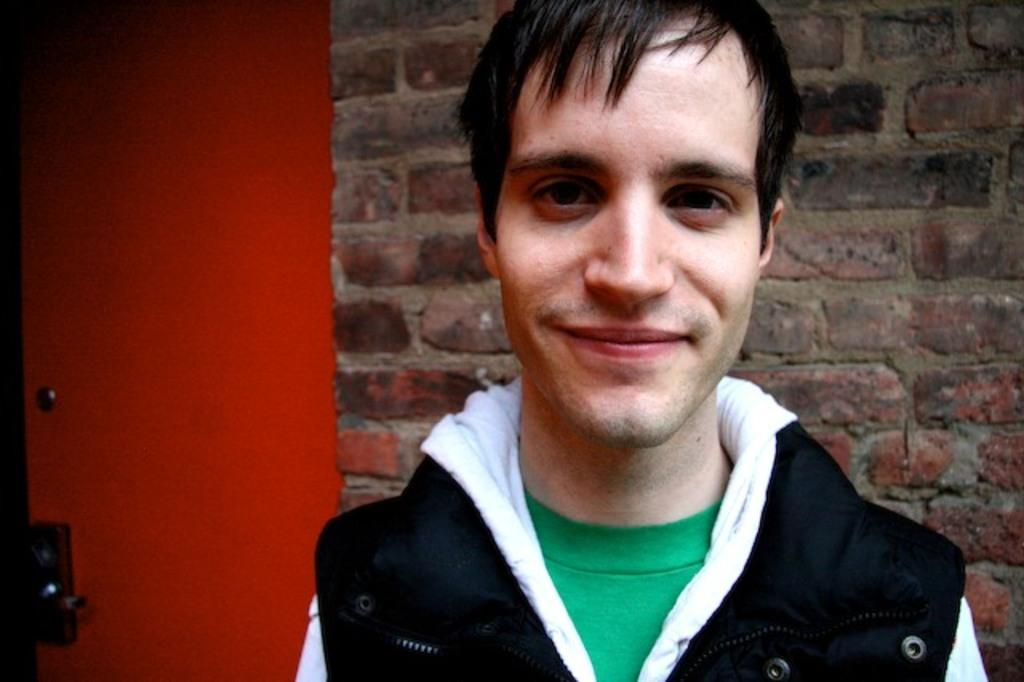Who is present in the image? There is a man in the image. What is the man's facial expression? The man is smiling. What is the color of the door in the image? There is a red color door in the image. What can be seen behind the man? There is a wall visible in the image. How many legs can be seen in the image? There is no information about legs in the image, as it only features a man, a door, and a wall. 